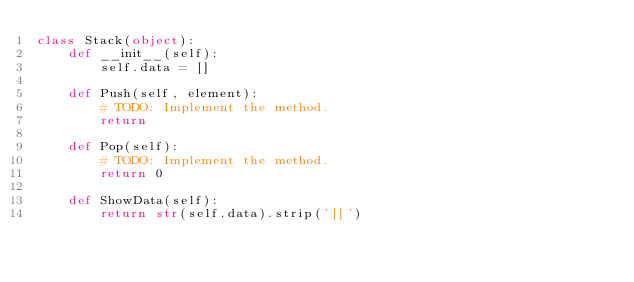<code> <loc_0><loc_0><loc_500><loc_500><_Python_>class Stack(object):
    def __init__(self):
        self.data = []
    
    def Push(self, element):
        # TODO: Implement the method.
        return
    
    def Pop(self):
        # TODO: Implement the method.
        return 0

    def ShowData(self):
        return str(self.data).strip('[]')</code> 